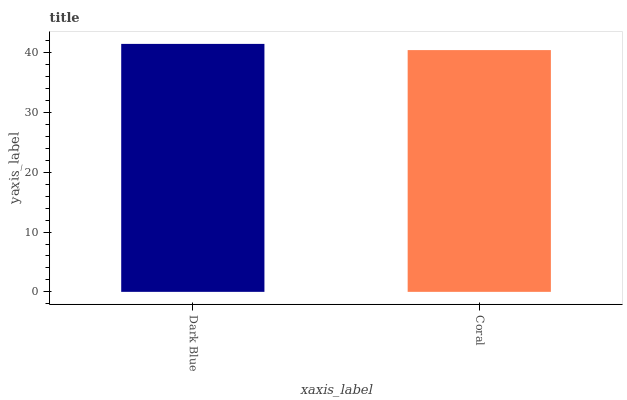Is Coral the minimum?
Answer yes or no. Yes. Is Dark Blue the maximum?
Answer yes or no. Yes. Is Coral the maximum?
Answer yes or no. No. Is Dark Blue greater than Coral?
Answer yes or no. Yes. Is Coral less than Dark Blue?
Answer yes or no. Yes. Is Coral greater than Dark Blue?
Answer yes or no. No. Is Dark Blue less than Coral?
Answer yes or no. No. Is Dark Blue the high median?
Answer yes or no. Yes. Is Coral the low median?
Answer yes or no. Yes. Is Coral the high median?
Answer yes or no. No. Is Dark Blue the low median?
Answer yes or no. No. 